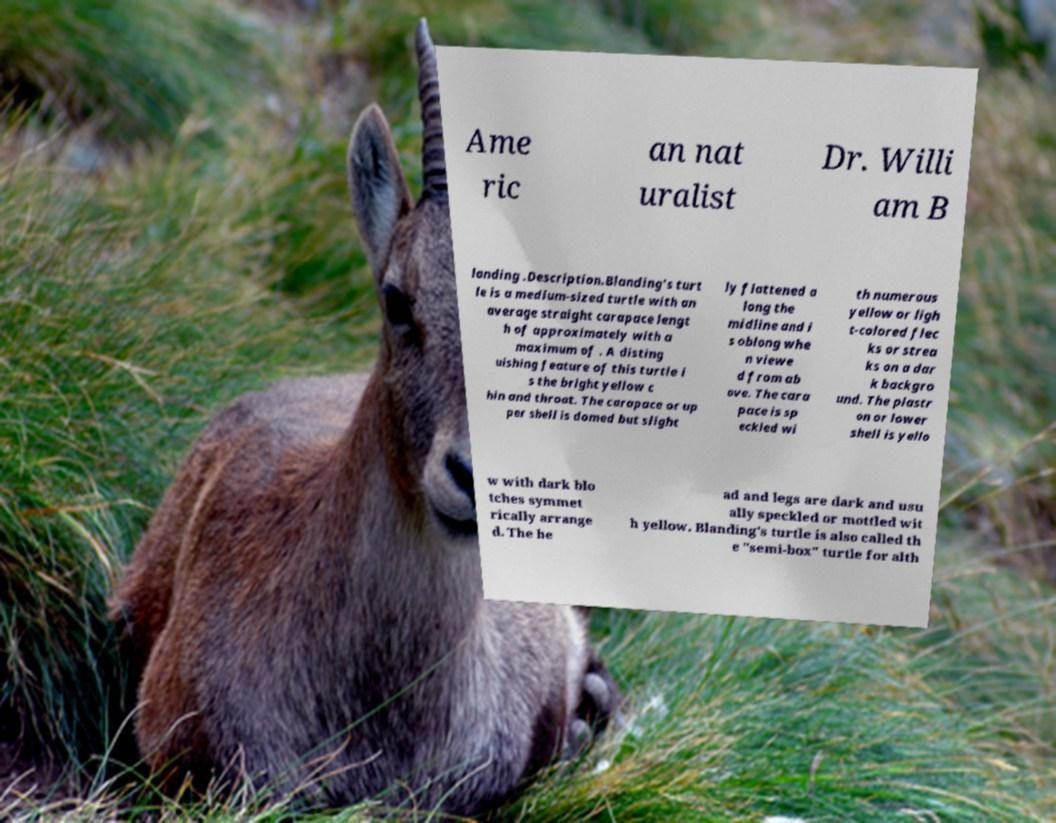Could you extract and type out the text from this image? Ame ric an nat uralist Dr. Willi am B landing .Description.Blanding's turt le is a medium-sized turtle with an average straight carapace lengt h of approximately with a maximum of . A disting uishing feature of this turtle i s the bright yellow c hin and throat. The carapace or up per shell is domed but slight ly flattened a long the midline and i s oblong whe n viewe d from ab ove. The cara pace is sp eckled wi th numerous yellow or ligh t-colored flec ks or strea ks on a dar k backgro und. The plastr on or lower shell is yello w with dark blo tches symmet rically arrange d. The he ad and legs are dark and usu ally speckled or mottled wit h yellow. Blanding's turtle is also called th e "semi-box" turtle for alth 